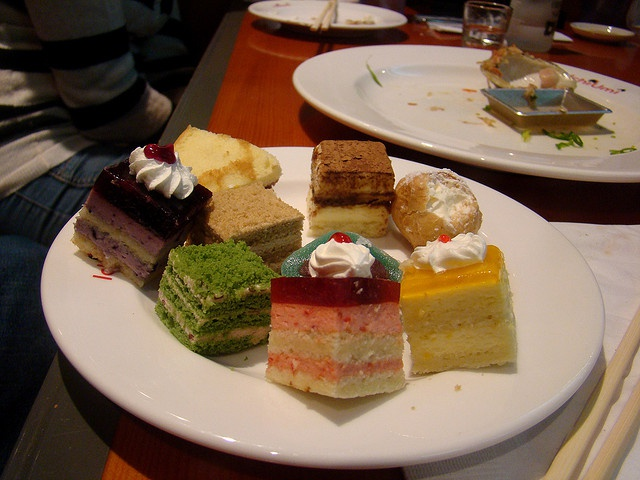Describe the objects in this image and their specific colors. I can see people in black and gray tones, dining table in black, maroon, and brown tones, cake in black, brown, gray, maroon, and tan tones, cake in black, olive, and tan tones, and cake in black, maroon, and gray tones in this image. 